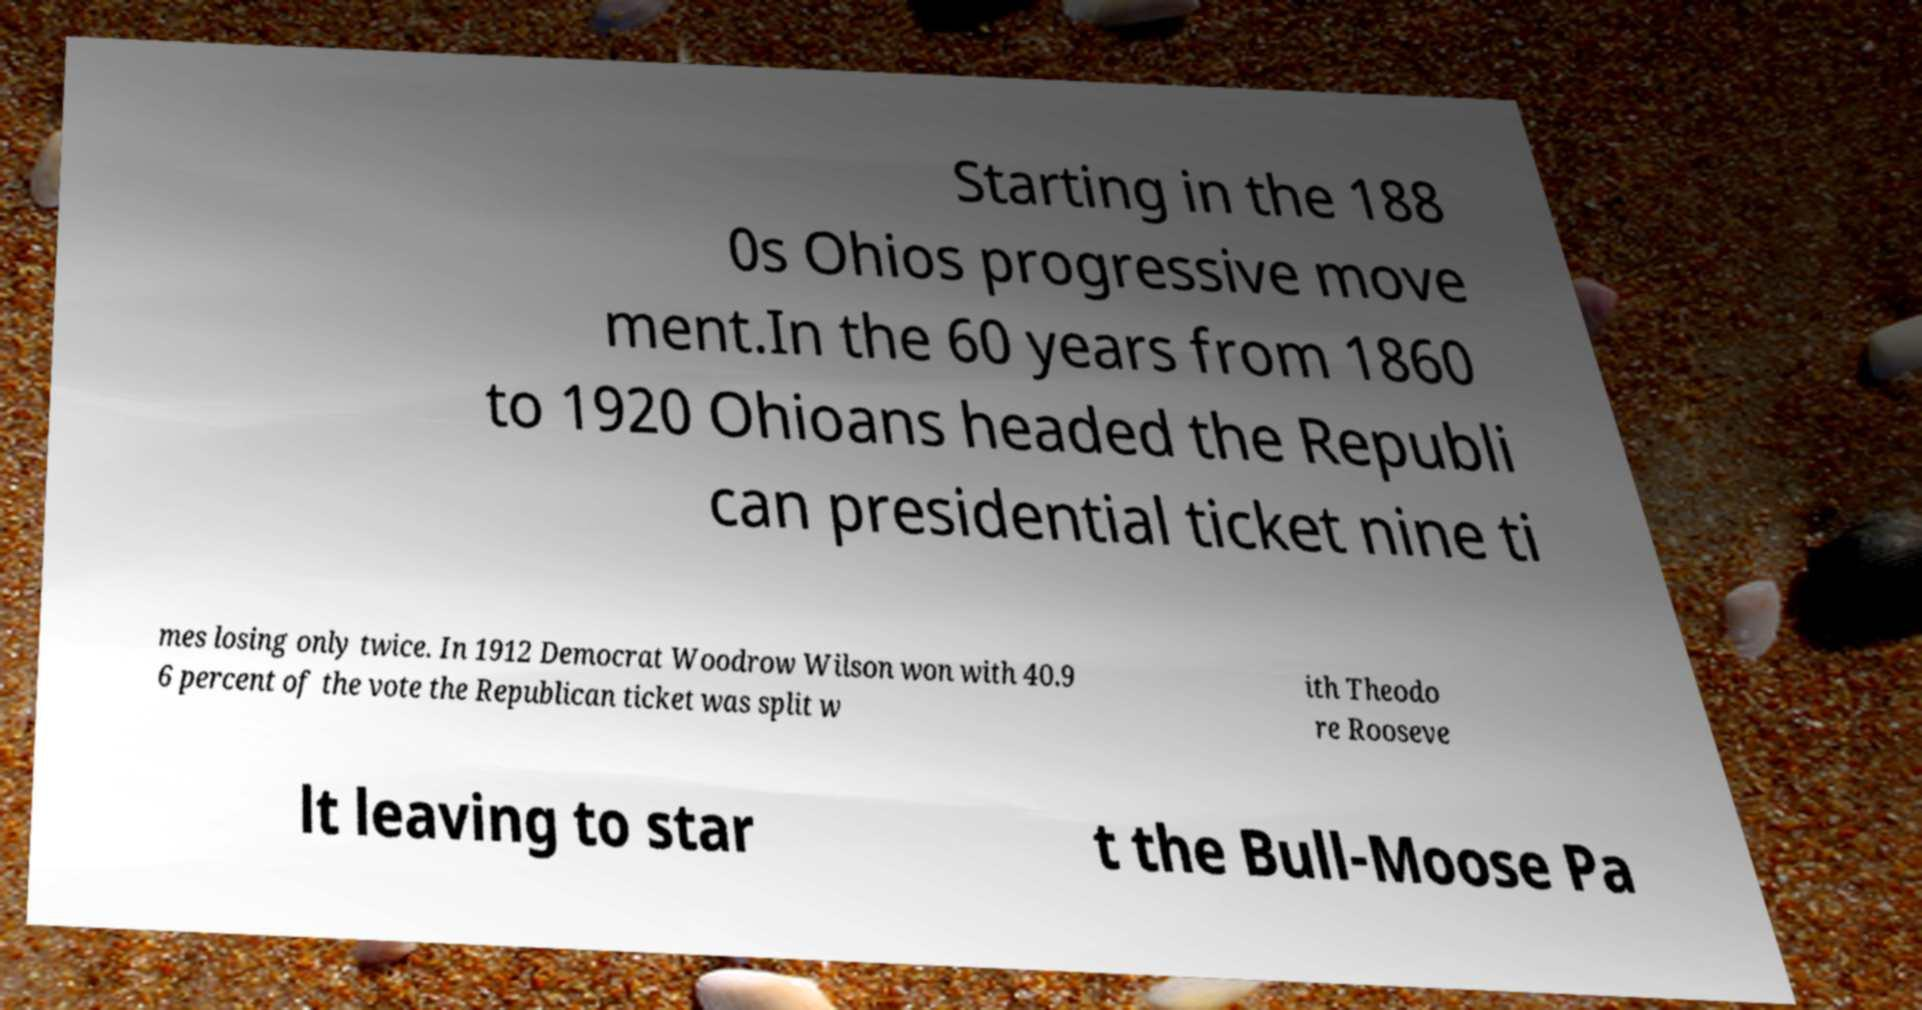For documentation purposes, I need the text within this image transcribed. Could you provide that? Starting in the 188 0s Ohios progressive move ment.In the 60 years from 1860 to 1920 Ohioans headed the Republi can presidential ticket nine ti mes losing only twice. In 1912 Democrat Woodrow Wilson won with 40.9 6 percent of the vote the Republican ticket was split w ith Theodo re Rooseve lt leaving to star t the Bull-Moose Pa 